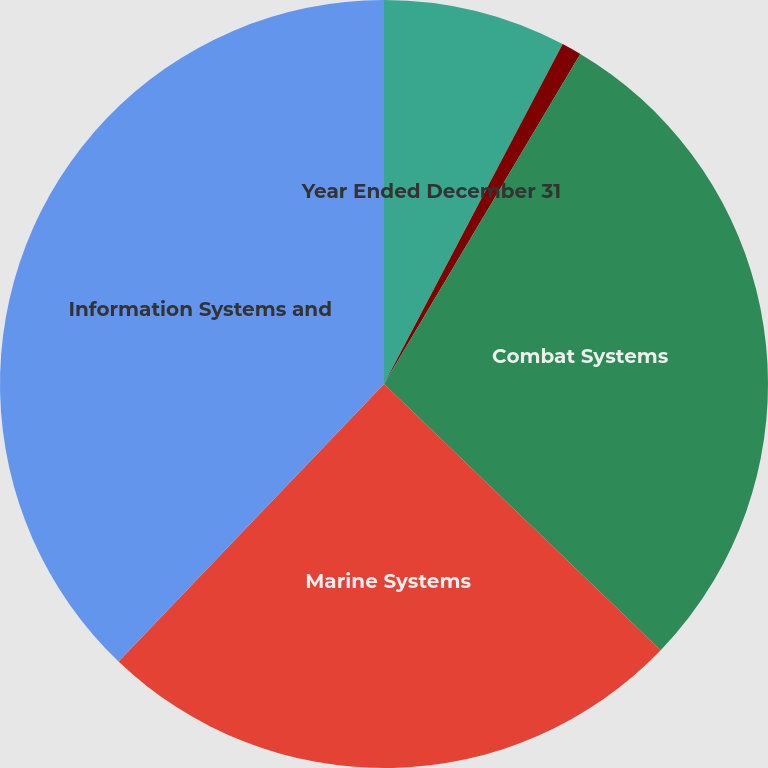<chart> <loc_0><loc_0><loc_500><loc_500><pie_chart><fcel>Year Ended December 31<fcel>Aerospace<fcel>Combat Systems<fcel>Marine Systems<fcel>Information Systems and<nl><fcel>7.7%<fcel>0.84%<fcel>28.65%<fcel>24.95%<fcel>37.85%<nl></chart> 